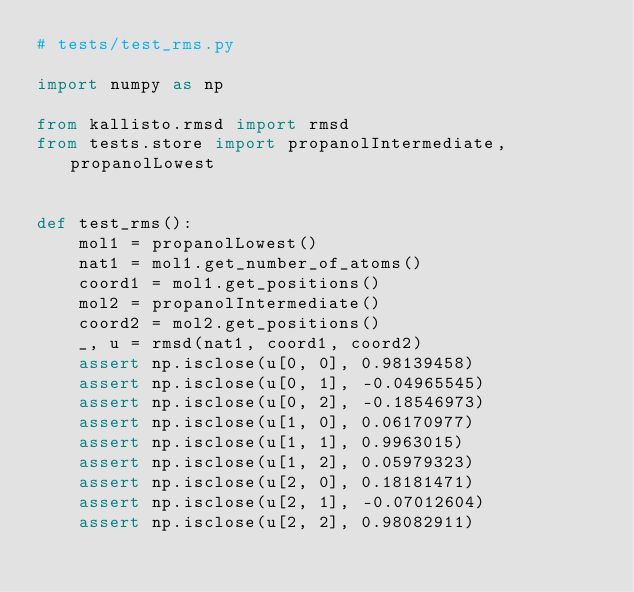<code> <loc_0><loc_0><loc_500><loc_500><_Python_># tests/test_rms.py

import numpy as np

from kallisto.rmsd import rmsd
from tests.store import propanolIntermediate, propanolLowest


def test_rms():
    mol1 = propanolLowest()
    nat1 = mol1.get_number_of_atoms()
    coord1 = mol1.get_positions()
    mol2 = propanolIntermediate()
    coord2 = mol2.get_positions()
    _, u = rmsd(nat1, coord1, coord2)
    assert np.isclose(u[0, 0], 0.98139458)
    assert np.isclose(u[0, 1], -0.04965545)
    assert np.isclose(u[0, 2], -0.18546973)
    assert np.isclose(u[1, 0], 0.06170977)
    assert np.isclose(u[1, 1], 0.9963015)
    assert np.isclose(u[1, 2], 0.05979323)
    assert np.isclose(u[2, 0], 0.18181471)
    assert np.isclose(u[2, 1], -0.07012604)
    assert np.isclose(u[2, 2], 0.98082911)
</code> 